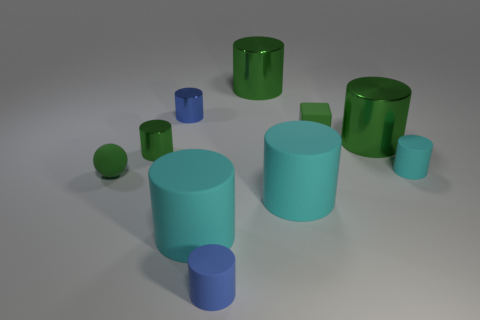Subtract all green cylinders. How many were subtracted if there are1green cylinders left? 2 Subtract all blue spheres. How many green cylinders are left? 3 Subtract 4 cylinders. How many cylinders are left? 4 Subtract all blue cylinders. How many cylinders are left? 6 Subtract all cyan cylinders. How many cylinders are left? 5 Subtract all red cylinders. Subtract all cyan balls. How many cylinders are left? 8 Subtract all balls. How many objects are left? 9 Subtract 0 gray cubes. How many objects are left? 10 Subtract all blue shiny cylinders. Subtract all tiny green cubes. How many objects are left? 8 Add 2 big rubber objects. How many big rubber objects are left? 4 